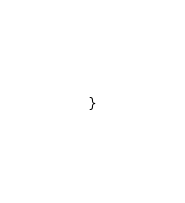<code> <loc_0><loc_0><loc_500><loc_500><_Rust_>}
</code> 